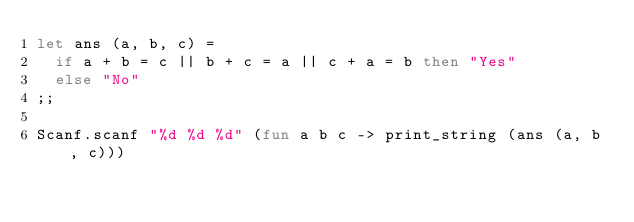<code> <loc_0><loc_0><loc_500><loc_500><_OCaml_>let ans (a, b, c) =
  if a + b = c || b + c = a || c + a = b then "Yes"
  else "No"
;;

Scanf.scanf "%d %d %d" (fun a b c -> print_string (ans (a, b, c)))
</code> 